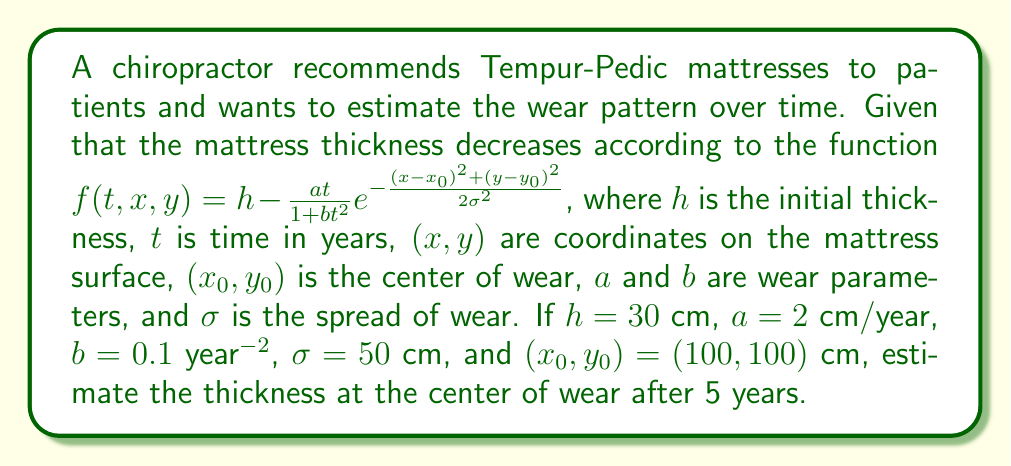Give your solution to this math problem. To solve this problem, we need to follow these steps:

1) We are given the wear function:
   $$f(t,x,y) = h - \frac{at}{1+bt^2} e^{-\frac{(x-x_0)^2+(y-y_0)^2}{2\sigma^2}}$$

2) We need to find $f(5,100,100)$, as we're interested in the thickness at the center of wear $(x_0,y_0)=(100,100)$ after 5 years.

3) At the center of wear, $(x-x_0)^2+(y-y_0)^2 = 0$, so $e^{-\frac{(x-x_0)^2+(y-y_0)^2}{2\sigma^2}} = e^0 = 1$

4) Substituting the given values:
   $$f(5,100,100) = 30 - \frac{2 \cdot 5}{1+0.1 \cdot 5^2} \cdot 1$$

5) Simplify:
   $$f(5,100,100) = 30 - \frac{10}{1+2.5}$$

6) Calculate:
   $$f(5,100,100) = 30 - \frac{10}{3.5} \approx 27.14$$

Therefore, the thickness at the center of wear after 5 years is approximately 27.14 cm.
Answer: 27.14 cm 